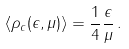Convert formula to latex. <formula><loc_0><loc_0><loc_500><loc_500>\left < \rho _ { c } ( \epsilon , \mu ) \right > = \frac { 1 } { 4 } \frac { \epsilon } { \mu } \, .</formula> 